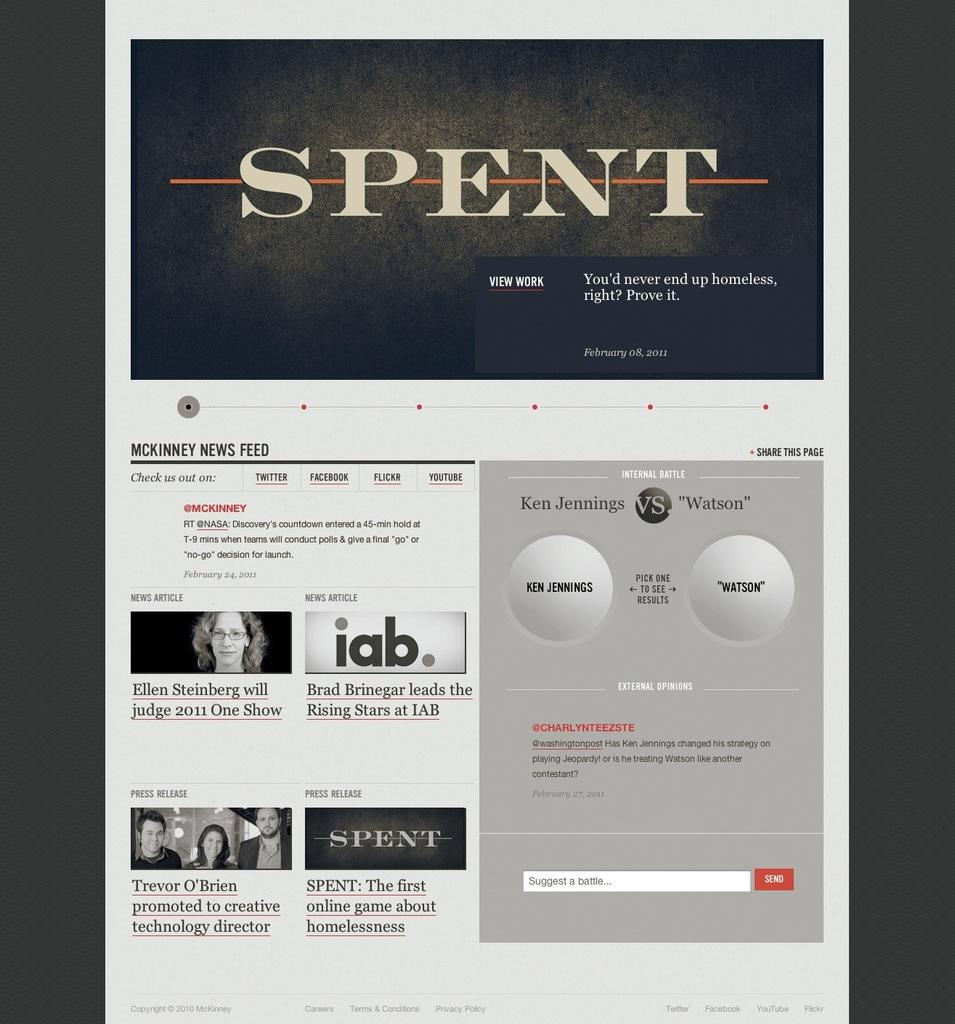<image>
Create a compact narrative representing the image presented. A screen grab of Spent with the tagline "You'd never end up homeless" 